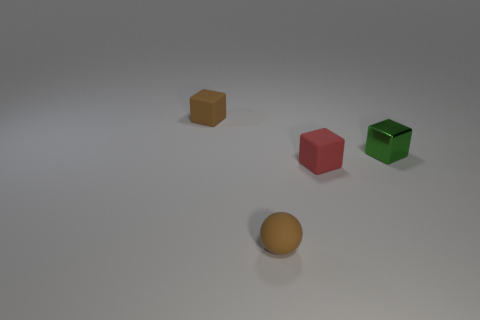Are any brown rubber spheres visible?
Provide a short and direct response. Yes. What material is the block that is on the left side of the brown matte sphere?
Provide a succinct answer. Rubber. What material is the object that is the same color as the small sphere?
Offer a very short reply. Rubber. How many large things are either red cubes or yellow things?
Keep it short and to the point. 0. What is the color of the matte sphere?
Make the answer very short. Brown. There is a rubber cube behind the small red object; are there any red objects that are behind it?
Your answer should be compact. No. Are there fewer objects behind the sphere than objects?
Your response must be concise. Yes. Do the small brown object in front of the green metal cube and the tiny red cube have the same material?
Provide a short and direct response. Yes. There is a sphere that is the same material as the tiny red thing; what color is it?
Your answer should be very brief. Brown. Are there fewer matte cubes in front of the tiny shiny cube than objects that are behind the small brown sphere?
Provide a short and direct response. Yes. 